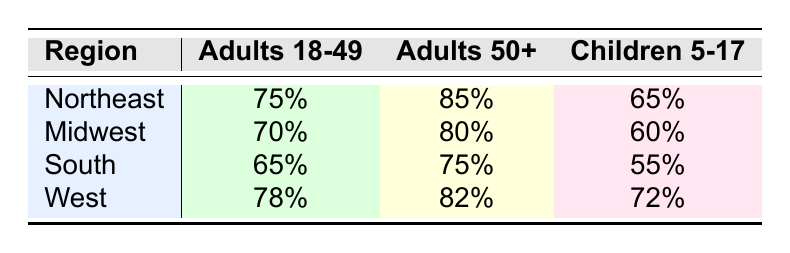What is the vaccination rate for Adults 50+ in the South? The table shows the vaccination rate for Adults 50+ in the South region, which is listed next to this demographic group's row. The rate is 75%.
Answer: 75% Which region has the highest vaccination rate for Children 5-17? By comparing the vaccination rates for Children 5-17 across all regions (Northeast: 65%, Midwest: 60%, South: 55%, West: 72%), the West has the highest rate at 72%.
Answer: West What is the average vaccination rate for Adults 18-49 across all regions? To calculate this: (75% + 70% + 65% + 78%) = 288%. Then divide by the number of regions (4): 288% / 4 = 72%.
Answer: 72% Is the vaccination rate for Adults 18-49 higher in the Northeast than in the Midwest? The vaccination rate for Adults 18-49 in the Northeast is 75%, while in the Midwest it is 70%. Since 75% is greater than 70%, the statement is true.
Answer: Yes Which demographic group has the lowest vaccination rate in the Midwest? In the Midwest, the vaccination rates are Adults 18-49: 70%, Adults 50+: 80%, and Children 5-17: 60%. Comparing these values, Children 5-17 have the lowest rate at 60%.
Answer: Children 5-17 What is the difference in vaccination rates for Adults 50+ between the Northeast and the South? The vaccination rates for Adults 50+ are 85% in the Northeast and 75% in the South. The difference is calculated as: 85% - 75% = 10%.
Answer: 10% Do more adults 50+ get vaccinated in the West than in the Northeast? The vaccination rate for Adults 50+ in the West is 82%, while in the Northeast it is 85%. Since 82% is less than 85%, the statement is false.
Answer: No What is the total vaccination rate for Children 5-17 across all regions? Adding the rates for Children 5-17 for all regions gives: 65% (Northeast) + 60% (Midwest) + 55% (South) + 72% (West) = 252%.
Answer: 252% 